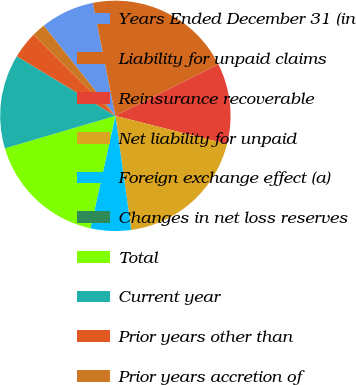<chart> <loc_0><loc_0><loc_500><loc_500><pie_chart><fcel>Years Ended December 31 (in<fcel>Liability for unpaid claims<fcel>Reinsurance recoverable<fcel>Net liability for unpaid<fcel>Foreign exchange effect (a)<fcel>Changes in net loss reserves<fcel>Total<fcel>Current year<fcel>Prior years other than<fcel>Prior years accretion of<nl><fcel>7.55%<fcel>20.75%<fcel>11.32%<fcel>18.86%<fcel>5.66%<fcel>0.0%<fcel>16.98%<fcel>13.21%<fcel>3.78%<fcel>1.89%<nl></chart> 